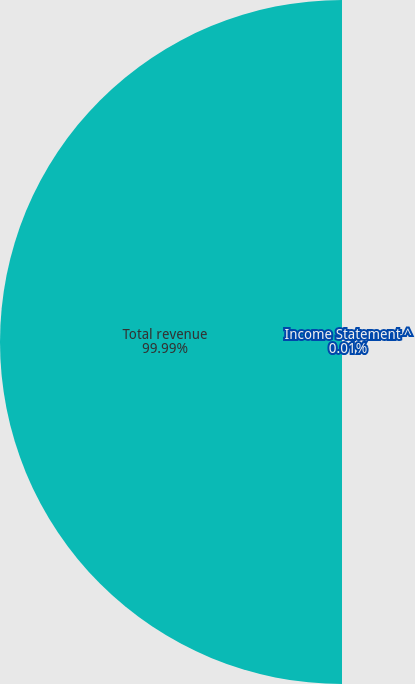Convert chart. <chart><loc_0><loc_0><loc_500><loc_500><pie_chart><fcel>Income Statement ^<fcel>Total revenue<nl><fcel>0.01%<fcel>99.99%<nl></chart> 